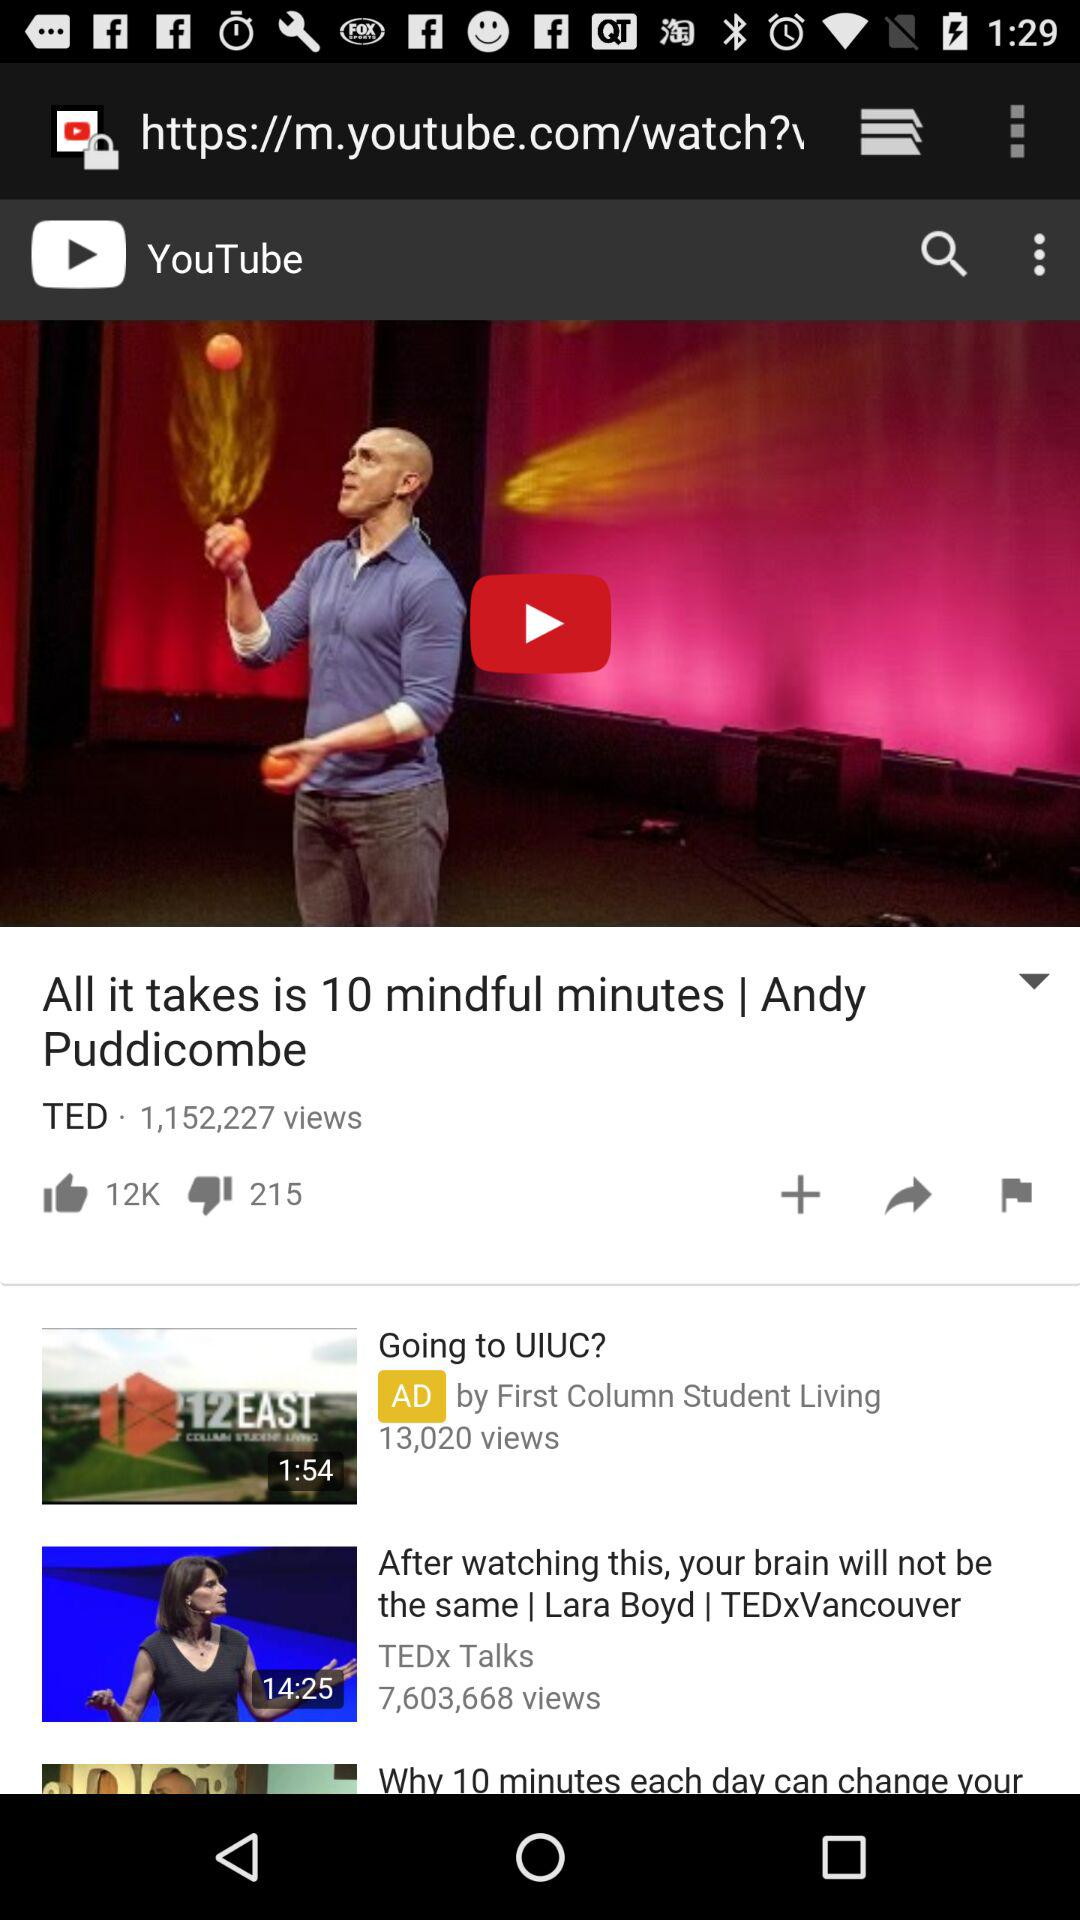What is the duration of the video "After watching this, your brain will not be the same"? The duration of the video is 14 minutes and 25 seconds. 